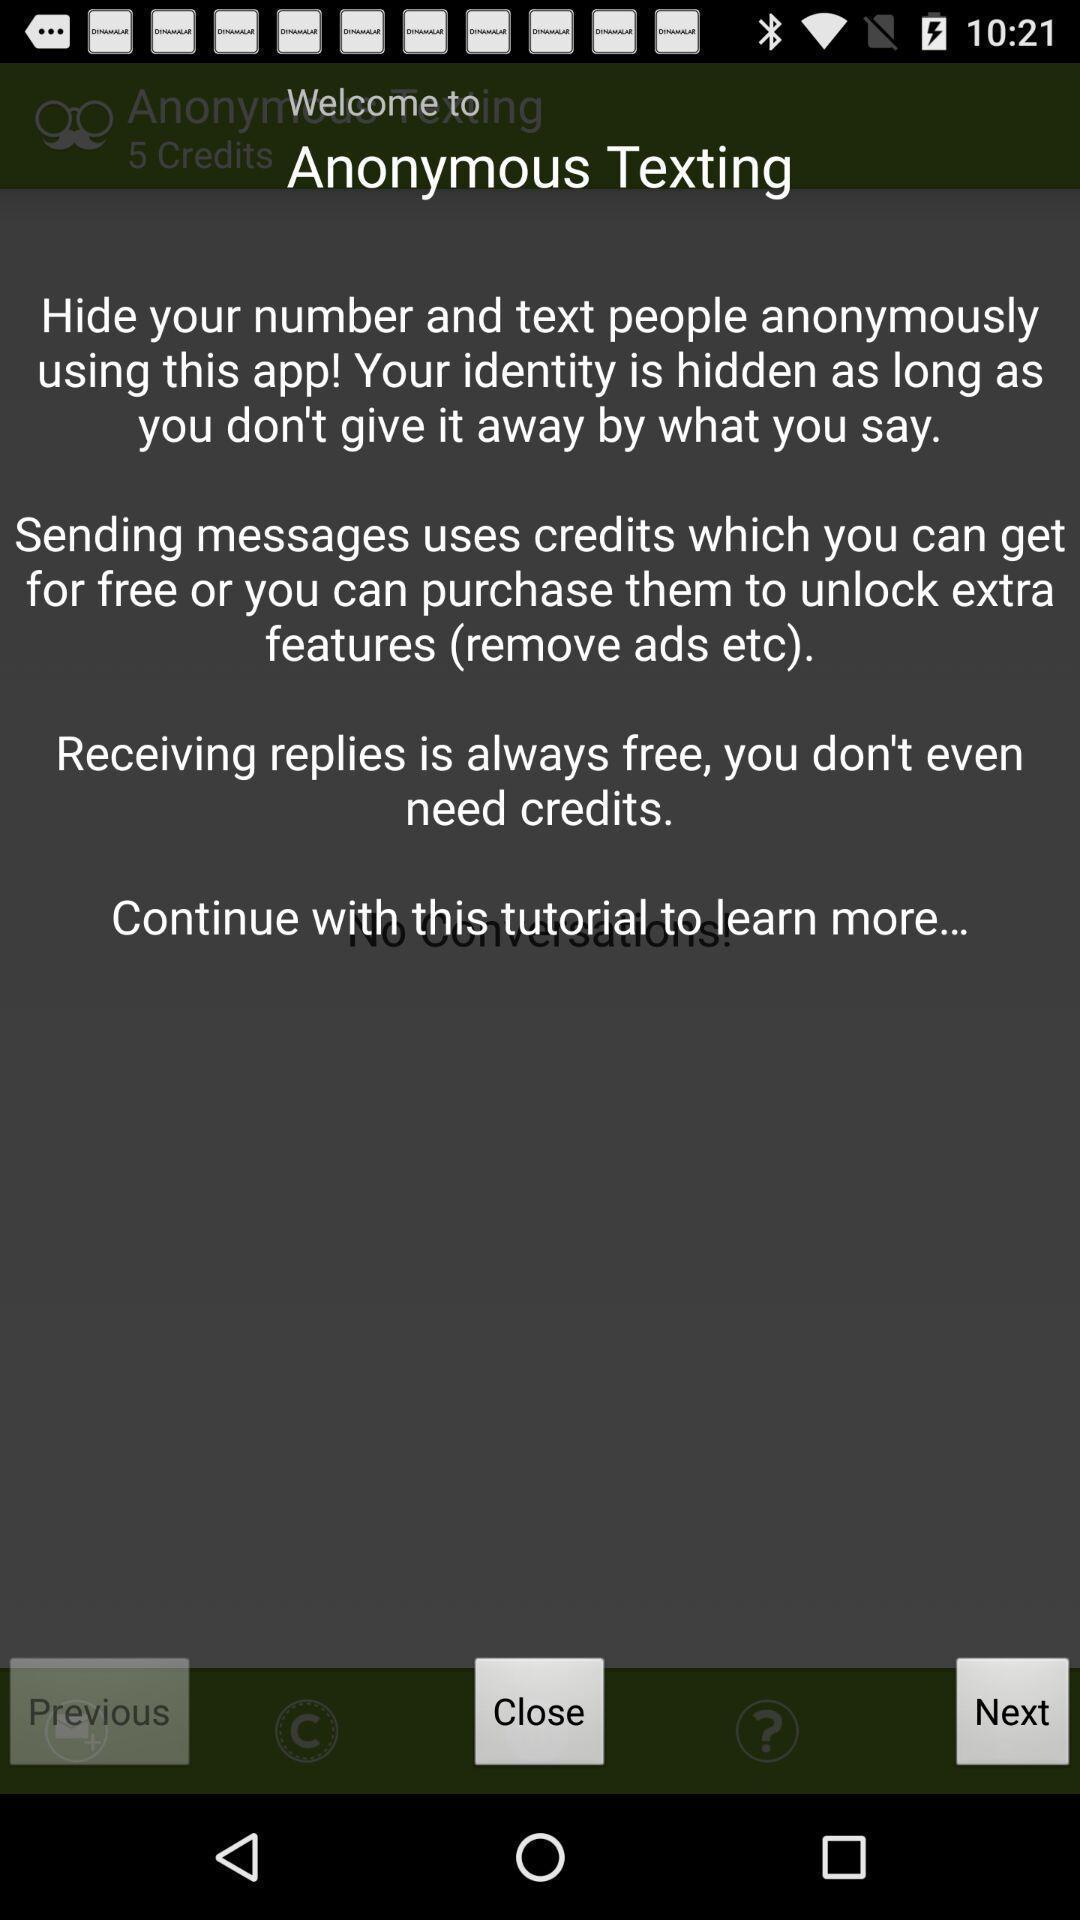Provide a description of this screenshot. Welcome page with description about a texting app. 